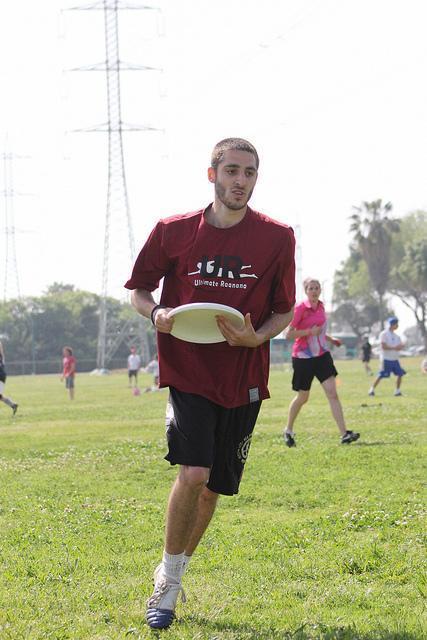How many people are there?
Give a very brief answer. 2. 